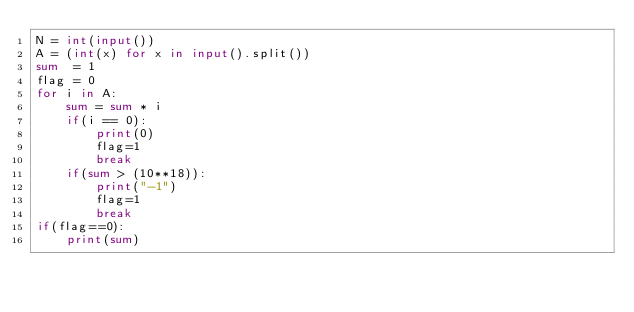Convert code to text. <code><loc_0><loc_0><loc_500><loc_500><_Python_>N = int(input())
A = (int(x) for x in input().split())
sum  = 1
flag = 0
for i in A:
    sum = sum * i
    if(i == 0):
        print(0)
        flag=1
        break
    if(sum > (10**18)):
        print("-1")
        flag=1
        break
if(flag==0):
    print(sum)
</code> 